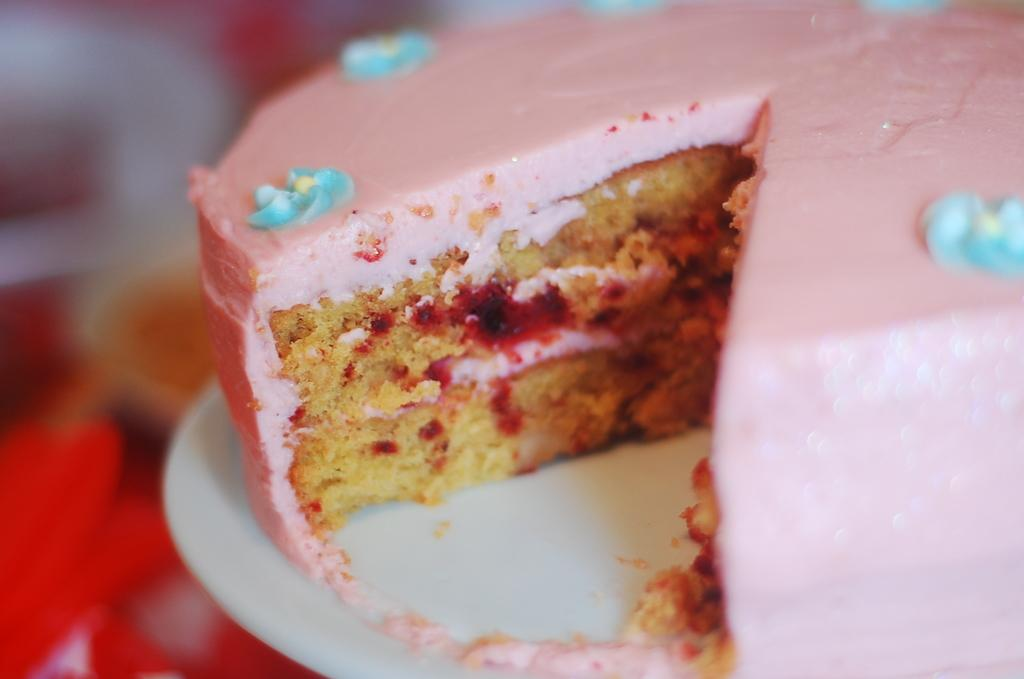What is the main subject in the image? There is a cake in the image. What is the color of the surface the cake is on? The cake is on a white surface. Are there any areas in the image that are blurred? Yes, there is a blurred view on the left side of the image and on the top of the image. What type of rice is being exchanged between the feet in the image? There are no feet or rice present in the image; it features a cake on a white surface with blurred views on the left side and the top. 